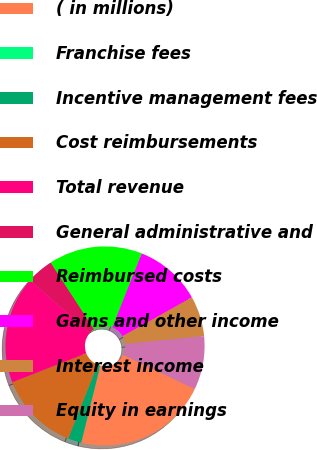Convert chart to OTSL. <chart><loc_0><loc_0><loc_500><loc_500><pie_chart><fcel>( in millions)<fcel>Franchise fees<fcel>Incentive management fees<fcel>Cost reimbursements<fcel>Total revenue<fcel>General administrative and<fcel>Reimbursed costs<fcel>Gains and other income<fcel>Interest income<fcel>Equity in earnings<nl><fcel>21.71%<fcel>0.02%<fcel>2.19%<fcel>13.04%<fcel>17.38%<fcel>4.36%<fcel>15.21%<fcel>10.87%<fcel>6.53%<fcel>8.7%<nl></chart> 